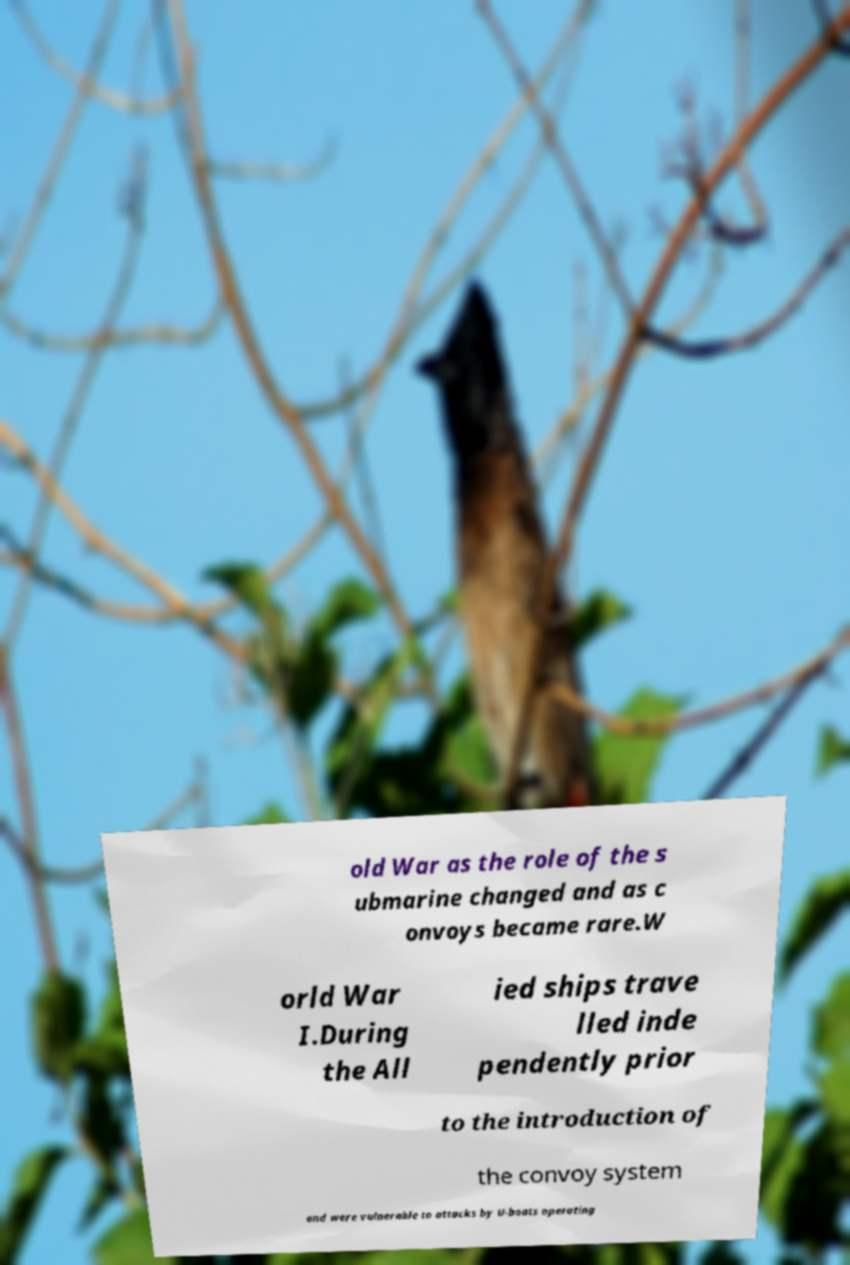For documentation purposes, I need the text within this image transcribed. Could you provide that? old War as the role of the s ubmarine changed and as c onvoys became rare.W orld War I.During the All ied ships trave lled inde pendently prior to the introduction of the convoy system and were vulnerable to attacks by U-boats operating 